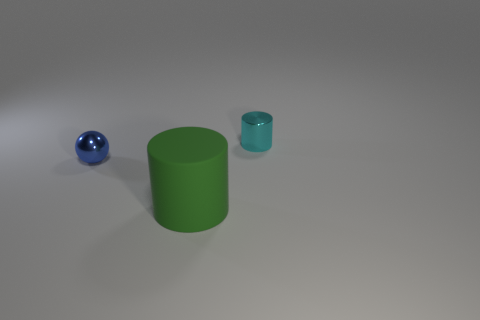Add 1 tiny cyan metal cylinders. How many objects exist? 4 Subtract all cylinders. How many objects are left? 1 Subtract 0 red spheres. How many objects are left? 3 Subtract all red spheres. Subtract all small shiny cylinders. How many objects are left? 2 Add 2 cylinders. How many cylinders are left? 4 Add 1 blue objects. How many blue objects exist? 2 